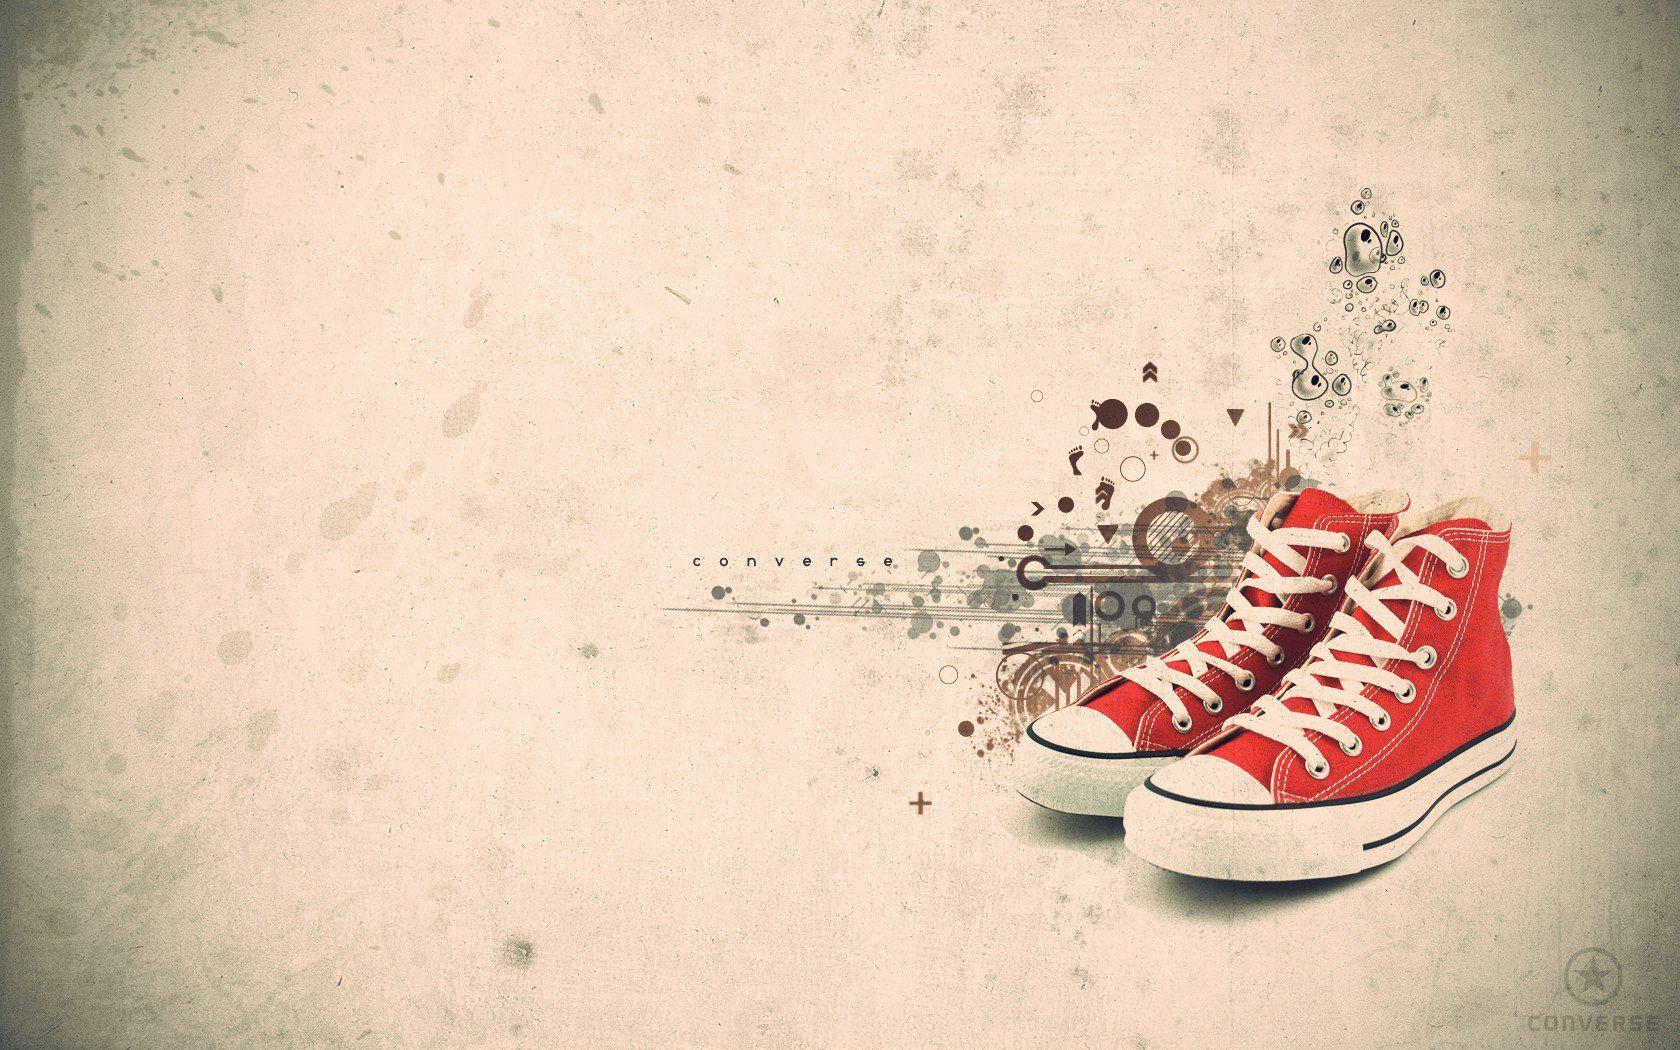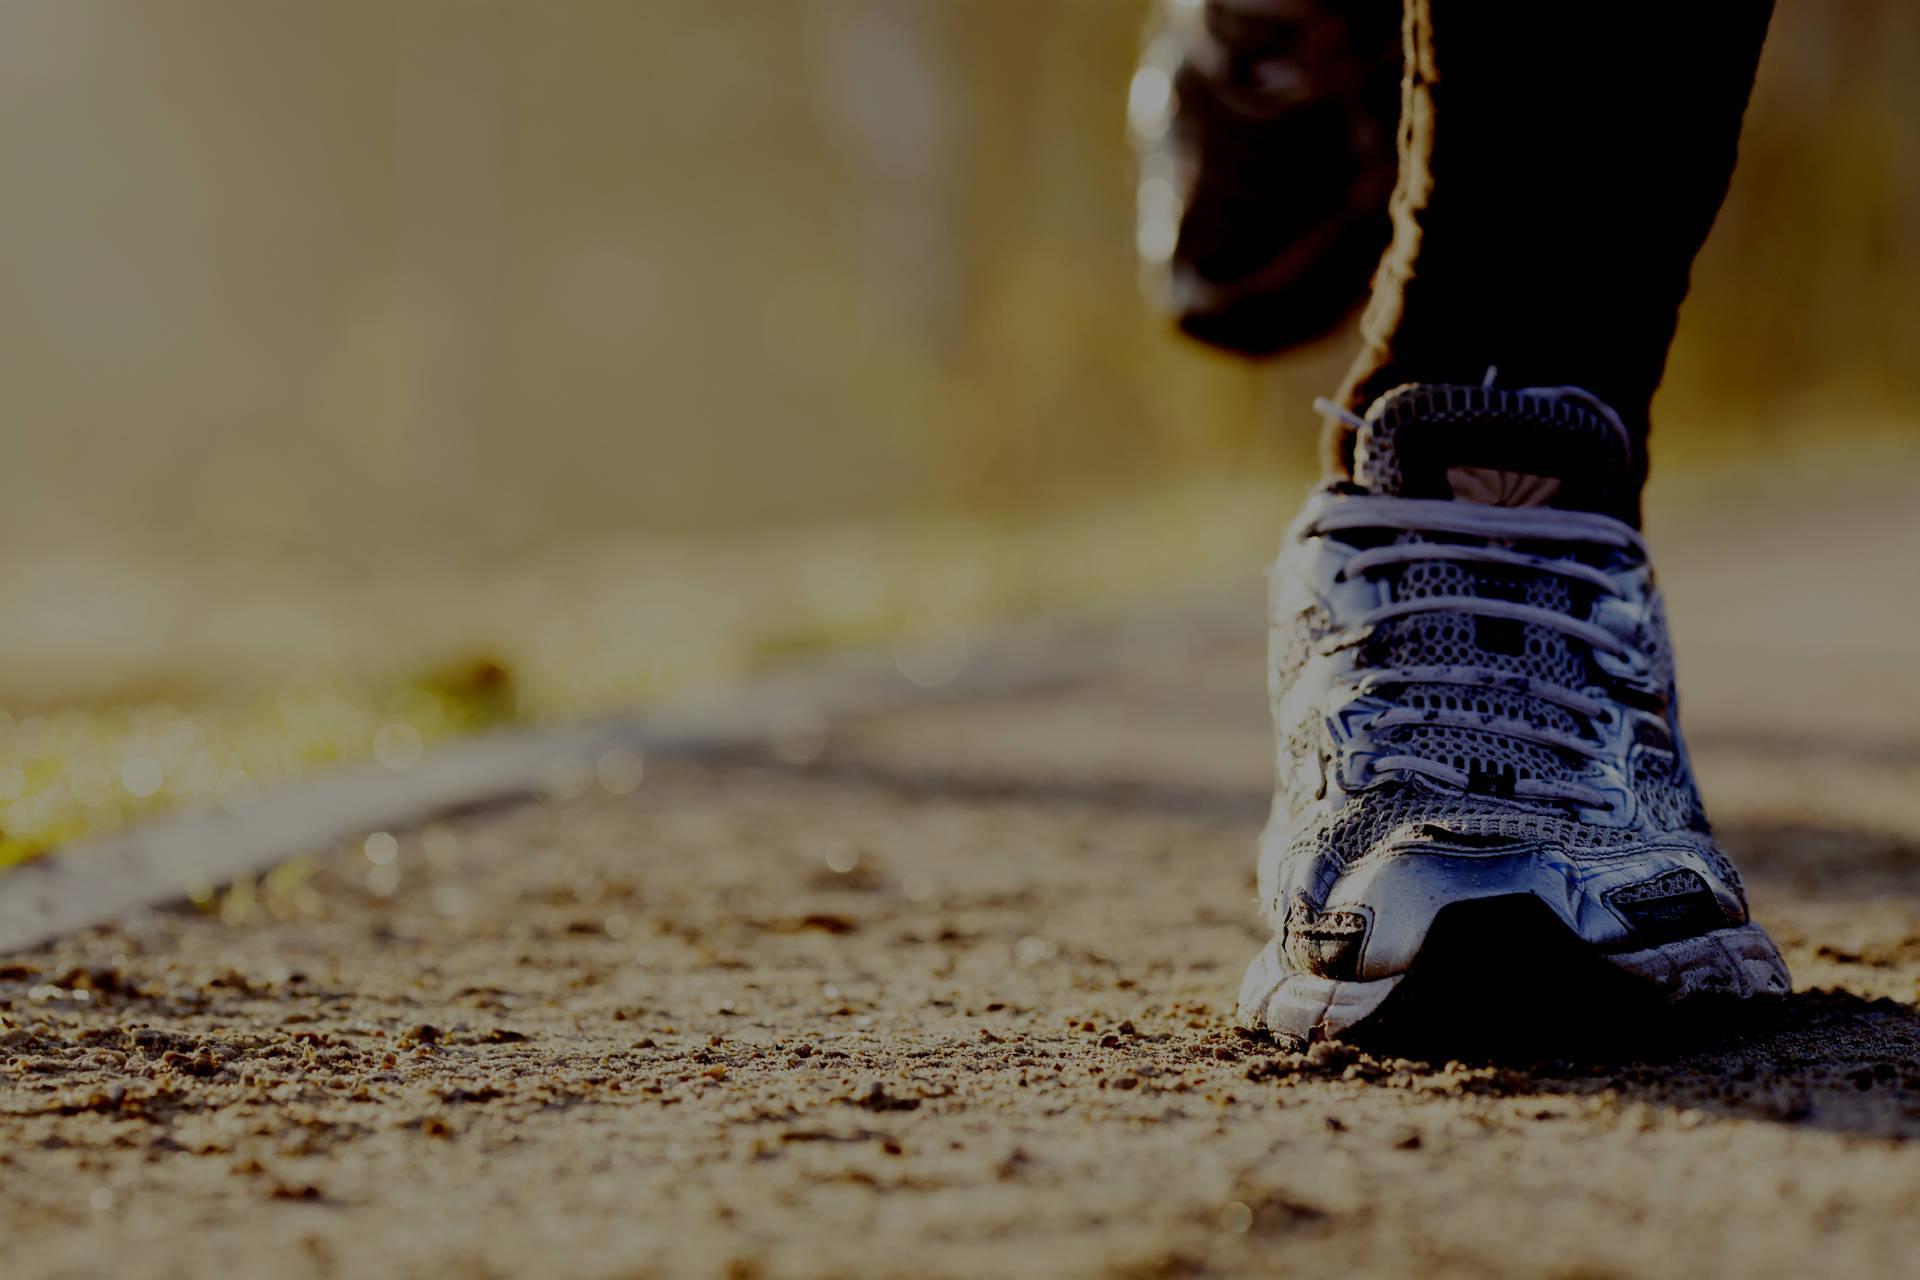The first image is the image on the left, the second image is the image on the right. Examine the images to the left and right. Is the description "One of the images shows a black shoe near a bottle of water." accurate? Answer yes or no. No. The first image is the image on the left, the second image is the image on the right. Examine the images to the left and right. Is the description "There is a pair of empty shoes in the right image." accurate? Answer yes or no. No. 